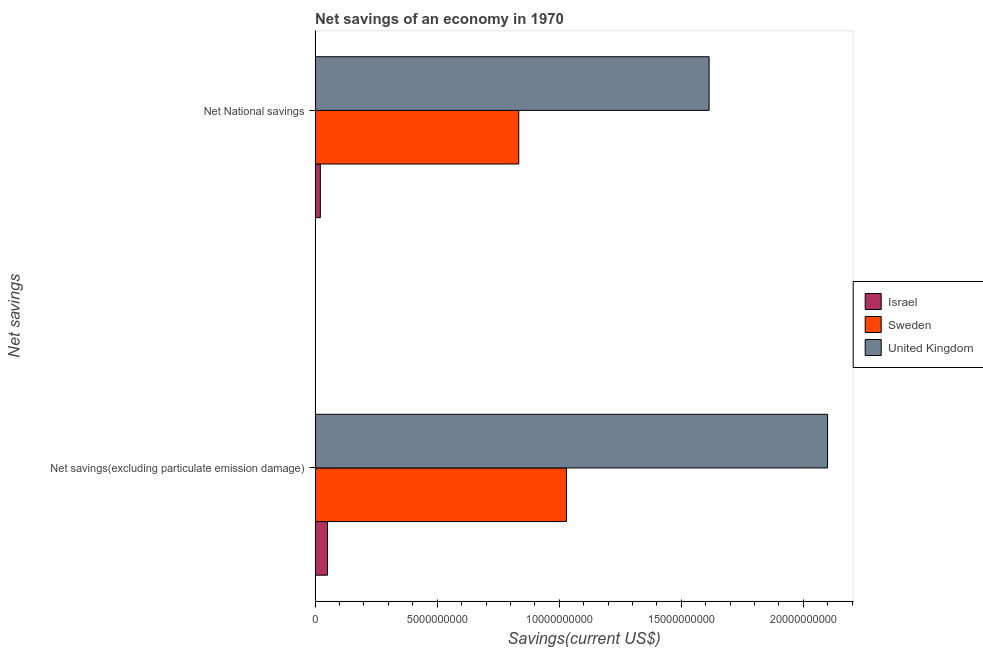How many different coloured bars are there?
Offer a terse response. 3. How many groups of bars are there?
Provide a succinct answer. 2. Are the number of bars on each tick of the Y-axis equal?
Offer a terse response. Yes. What is the label of the 2nd group of bars from the top?
Ensure brevity in your answer.  Net savings(excluding particulate emission damage). What is the net savings(excluding particulate emission damage) in Israel?
Offer a very short reply. 5.08e+08. Across all countries, what is the maximum net savings(excluding particulate emission damage)?
Ensure brevity in your answer.  2.10e+1. Across all countries, what is the minimum net savings(excluding particulate emission damage)?
Your answer should be very brief. 5.08e+08. In which country was the net savings(excluding particulate emission damage) minimum?
Offer a very short reply. Israel. What is the total net savings(excluding particulate emission damage) in the graph?
Offer a terse response. 3.18e+1. What is the difference between the net savings(excluding particulate emission damage) in Sweden and that in Israel?
Your answer should be very brief. 9.79e+09. What is the difference between the net savings(excluding particulate emission damage) in Israel and the net national savings in United Kingdom?
Keep it short and to the point. -1.56e+1. What is the average net national savings per country?
Give a very brief answer. 8.23e+09. What is the difference between the net savings(excluding particulate emission damage) and net national savings in Sweden?
Give a very brief answer. 1.95e+09. What is the ratio of the net national savings in Israel to that in Sweden?
Offer a very short reply. 0.03. What does the 1st bar from the top in Net National savings represents?
Offer a very short reply. United Kingdom. What does the 2nd bar from the bottom in Net National savings represents?
Your response must be concise. Sweden. How many bars are there?
Offer a very short reply. 6. How many countries are there in the graph?
Provide a short and direct response. 3. What is the difference between two consecutive major ticks on the X-axis?
Give a very brief answer. 5.00e+09. Where does the legend appear in the graph?
Give a very brief answer. Center right. How many legend labels are there?
Offer a very short reply. 3. What is the title of the graph?
Your answer should be compact. Net savings of an economy in 1970. What is the label or title of the X-axis?
Your answer should be compact. Savings(current US$). What is the label or title of the Y-axis?
Make the answer very short. Net savings. What is the Savings(current US$) in Israel in Net savings(excluding particulate emission damage)?
Provide a short and direct response. 5.08e+08. What is the Savings(current US$) in Sweden in Net savings(excluding particulate emission damage)?
Keep it short and to the point. 1.03e+1. What is the Savings(current US$) of United Kingdom in Net savings(excluding particulate emission damage)?
Your answer should be very brief. 2.10e+1. What is the Savings(current US$) in Israel in Net National savings?
Your answer should be very brief. 2.15e+08. What is the Savings(current US$) in Sweden in Net National savings?
Your response must be concise. 8.34e+09. What is the Savings(current US$) of United Kingdom in Net National savings?
Offer a terse response. 1.61e+1. Across all Net savings, what is the maximum Savings(current US$) in Israel?
Keep it short and to the point. 5.08e+08. Across all Net savings, what is the maximum Savings(current US$) of Sweden?
Keep it short and to the point. 1.03e+1. Across all Net savings, what is the maximum Savings(current US$) of United Kingdom?
Provide a succinct answer. 2.10e+1. Across all Net savings, what is the minimum Savings(current US$) in Israel?
Your response must be concise. 2.15e+08. Across all Net savings, what is the minimum Savings(current US$) in Sweden?
Provide a succinct answer. 8.34e+09. Across all Net savings, what is the minimum Savings(current US$) of United Kingdom?
Keep it short and to the point. 1.61e+1. What is the total Savings(current US$) in Israel in the graph?
Make the answer very short. 7.23e+08. What is the total Savings(current US$) of Sweden in the graph?
Make the answer very short. 1.86e+1. What is the total Savings(current US$) of United Kingdom in the graph?
Provide a succinct answer. 3.71e+1. What is the difference between the Savings(current US$) in Israel in Net savings(excluding particulate emission damage) and that in Net National savings?
Keep it short and to the point. 2.93e+08. What is the difference between the Savings(current US$) of Sweden in Net savings(excluding particulate emission damage) and that in Net National savings?
Your response must be concise. 1.95e+09. What is the difference between the Savings(current US$) in United Kingdom in Net savings(excluding particulate emission damage) and that in Net National savings?
Offer a terse response. 4.85e+09. What is the difference between the Savings(current US$) in Israel in Net savings(excluding particulate emission damage) and the Savings(current US$) in Sweden in Net National savings?
Your response must be concise. -7.83e+09. What is the difference between the Savings(current US$) of Israel in Net savings(excluding particulate emission damage) and the Savings(current US$) of United Kingdom in Net National savings?
Your answer should be compact. -1.56e+1. What is the difference between the Savings(current US$) of Sweden in Net savings(excluding particulate emission damage) and the Savings(current US$) of United Kingdom in Net National savings?
Your response must be concise. -5.84e+09. What is the average Savings(current US$) in Israel per Net savings?
Make the answer very short. 3.61e+08. What is the average Savings(current US$) of Sweden per Net savings?
Provide a short and direct response. 9.32e+09. What is the average Savings(current US$) of United Kingdom per Net savings?
Offer a very short reply. 1.86e+1. What is the difference between the Savings(current US$) in Israel and Savings(current US$) in Sweden in Net savings(excluding particulate emission damage)?
Give a very brief answer. -9.79e+09. What is the difference between the Savings(current US$) in Israel and Savings(current US$) in United Kingdom in Net savings(excluding particulate emission damage)?
Your answer should be compact. -2.05e+1. What is the difference between the Savings(current US$) of Sweden and Savings(current US$) of United Kingdom in Net savings(excluding particulate emission damage)?
Provide a succinct answer. -1.07e+1. What is the difference between the Savings(current US$) of Israel and Savings(current US$) of Sweden in Net National savings?
Your answer should be compact. -8.13e+09. What is the difference between the Savings(current US$) of Israel and Savings(current US$) of United Kingdom in Net National savings?
Offer a terse response. -1.59e+1. What is the difference between the Savings(current US$) in Sweden and Savings(current US$) in United Kingdom in Net National savings?
Ensure brevity in your answer.  -7.80e+09. What is the ratio of the Savings(current US$) of Israel in Net savings(excluding particulate emission damage) to that in Net National savings?
Your answer should be very brief. 2.37. What is the ratio of the Savings(current US$) in Sweden in Net savings(excluding particulate emission damage) to that in Net National savings?
Ensure brevity in your answer.  1.23. What is the ratio of the Savings(current US$) of United Kingdom in Net savings(excluding particulate emission damage) to that in Net National savings?
Ensure brevity in your answer.  1.3. What is the difference between the highest and the second highest Savings(current US$) in Israel?
Your answer should be very brief. 2.93e+08. What is the difference between the highest and the second highest Savings(current US$) of Sweden?
Your answer should be compact. 1.95e+09. What is the difference between the highest and the second highest Savings(current US$) of United Kingdom?
Give a very brief answer. 4.85e+09. What is the difference between the highest and the lowest Savings(current US$) of Israel?
Give a very brief answer. 2.93e+08. What is the difference between the highest and the lowest Savings(current US$) in Sweden?
Your response must be concise. 1.95e+09. What is the difference between the highest and the lowest Savings(current US$) in United Kingdom?
Your answer should be compact. 4.85e+09. 